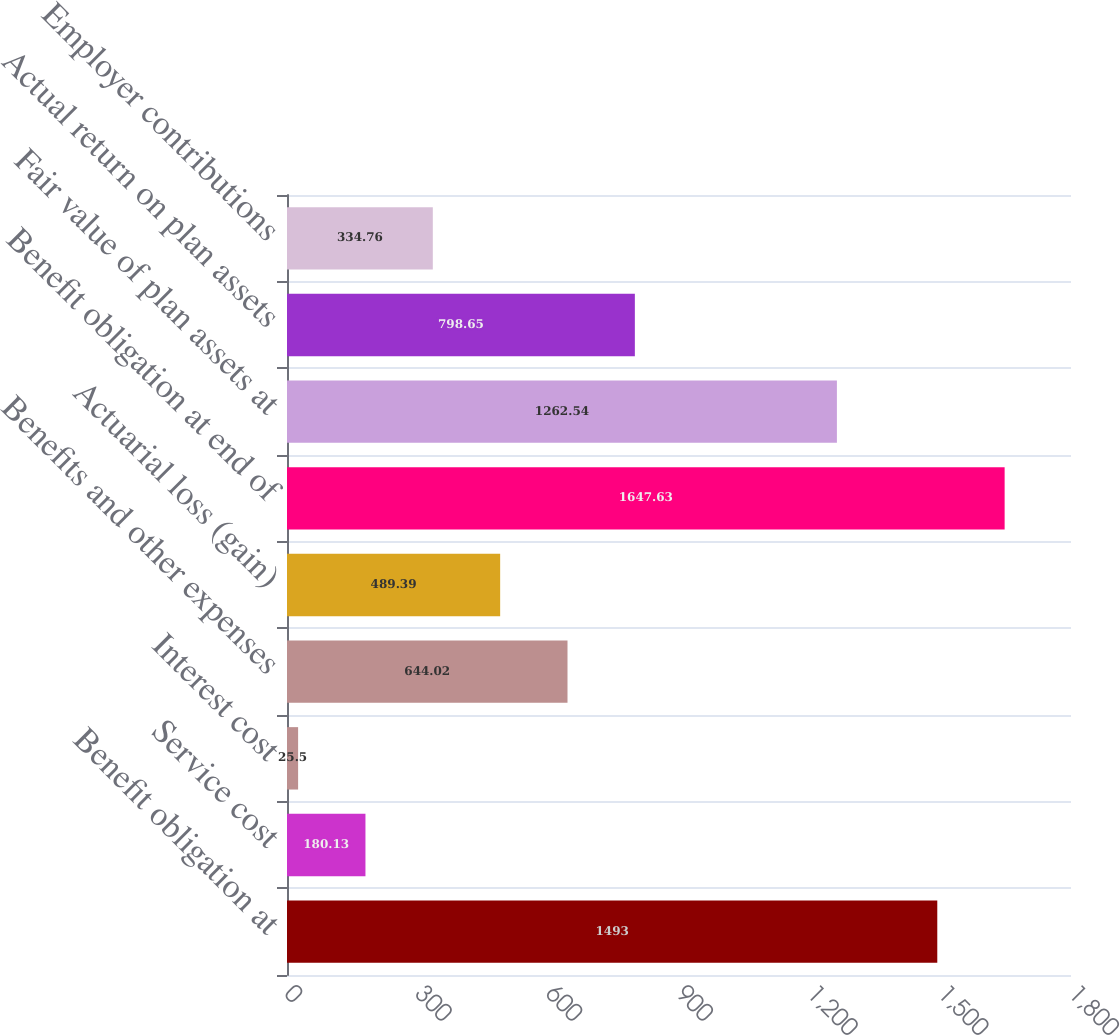Convert chart. <chart><loc_0><loc_0><loc_500><loc_500><bar_chart><fcel>Benefit obligation at<fcel>Service cost<fcel>Interest cost<fcel>Benefits and other expenses<fcel>Actuarial loss (gain)<fcel>Benefit obligation at end of<fcel>Fair value of plan assets at<fcel>Actual return on plan assets<fcel>Employer contributions<nl><fcel>1493<fcel>180.13<fcel>25.5<fcel>644.02<fcel>489.39<fcel>1647.63<fcel>1262.54<fcel>798.65<fcel>334.76<nl></chart> 